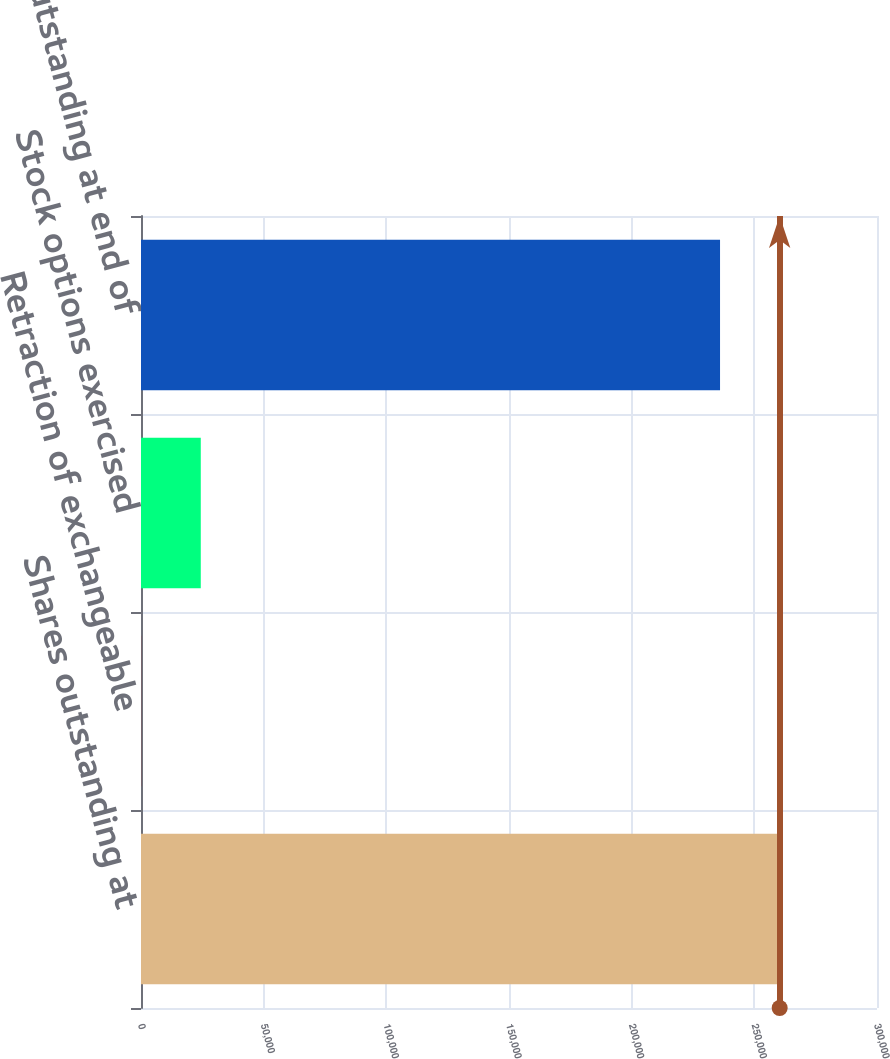Convert chart to OTSL. <chart><loc_0><loc_0><loc_500><loc_500><bar_chart><fcel>Shares outstanding at<fcel>Retraction of exchangeable<fcel>Stock options exercised<fcel>Shares outstanding at end of<nl><fcel>260328<fcel>57<fcel>24365.1<fcel>236020<nl></chart> 